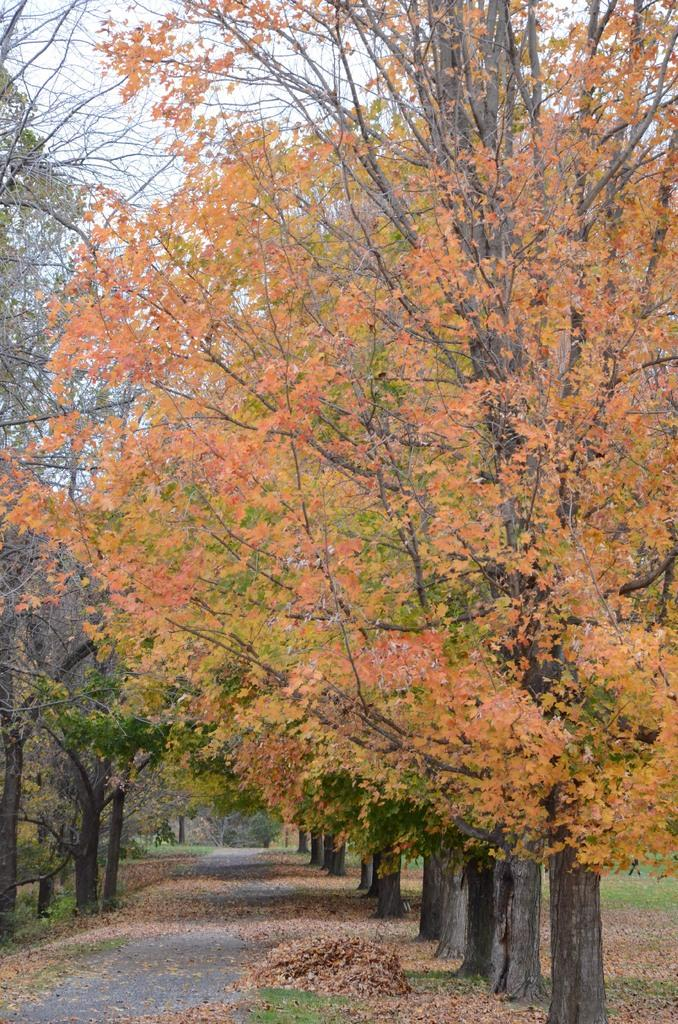What type of trees can be seen in the image? There are trees in green color and trees in orange color in the image. Can you describe the color of the sky in the image? The sky is visible in the image and appears to be white. What caption is written on the trees in the image? There is no caption written on the trees in the image. Are there any people playing in the image? The image does not show any people or activities like playing. 